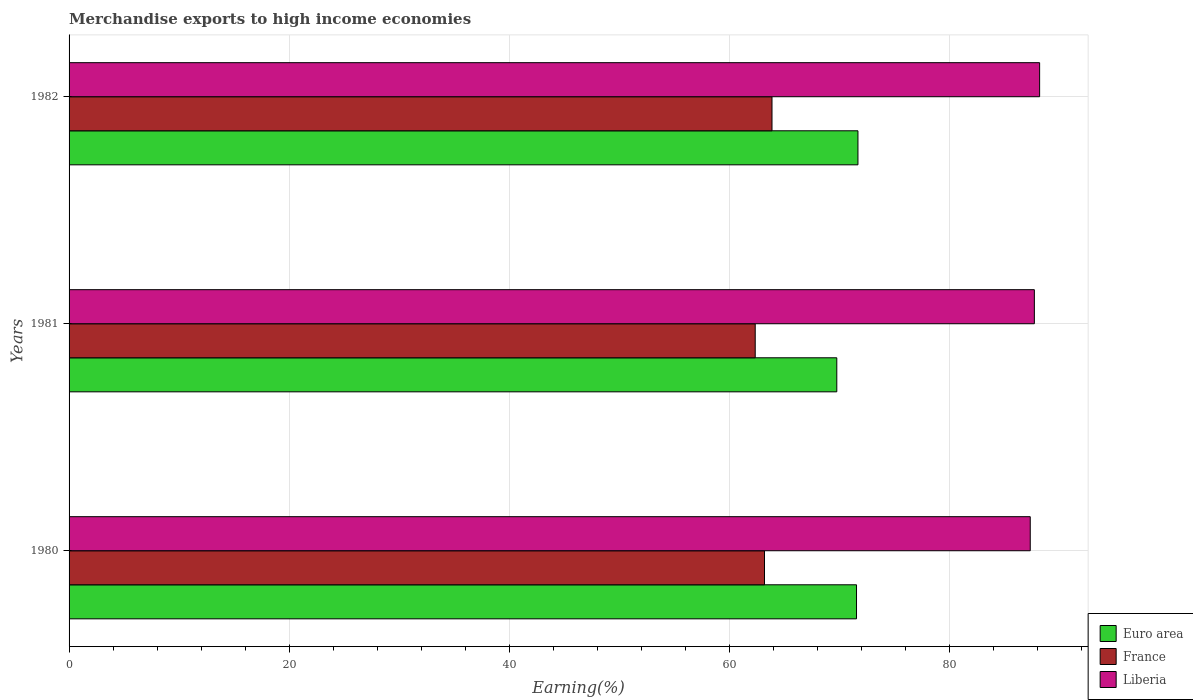How many different coloured bars are there?
Offer a terse response. 3. Are the number of bars per tick equal to the number of legend labels?
Your answer should be very brief. Yes. Are the number of bars on each tick of the Y-axis equal?
Keep it short and to the point. Yes. How many bars are there on the 1st tick from the top?
Ensure brevity in your answer.  3. In how many cases, is the number of bars for a given year not equal to the number of legend labels?
Provide a succinct answer. 0. What is the percentage of amount earned from merchandise exports in Liberia in 1981?
Provide a succinct answer. 87.71. Across all years, what is the maximum percentage of amount earned from merchandise exports in Liberia?
Provide a short and direct response. 88.19. Across all years, what is the minimum percentage of amount earned from merchandise exports in Liberia?
Make the answer very short. 87.34. What is the total percentage of amount earned from merchandise exports in Liberia in the graph?
Your response must be concise. 263.24. What is the difference between the percentage of amount earned from merchandise exports in Euro area in 1980 and that in 1982?
Your answer should be compact. -0.13. What is the difference between the percentage of amount earned from merchandise exports in Liberia in 1980 and the percentage of amount earned from merchandise exports in France in 1982?
Give a very brief answer. 23.47. What is the average percentage of amount earned from merchandise exports in France per year?
Keep it short and to the point. 63.14. In the year 1981, what is the difference between the percentage of amount earned from merchandise exports in France and percentage of amount earned from merchandise exports in Liberia?
Your response must be concise. -25.36. What is the ratio of the percentage of amount earned from merchandise exports in Liberia in 1981 to that in 1982?
Make the answer very short. 0.99. What is the difference between the highest and the second highest percentage of amount earned from merchandise exports in Liberia?
Your answer should be very brief. 0.48. What is the difference between the highest and the lowest percentage of amount earned from merchandise exports in Euro area?
Ensure brevity in your answer.  1.92. In how many years, is the percentage of amount earned from merchandise exports in Liberia greater than the average percentage of amount earned from merchandise exports in Liberia taken over all years?
Your response must be concise. 1. What does the 1st bar from the top in 1980 represents?
Offer a very short reply. Liberia. Does the graph contain grids?
Make the answer very short. Yes. Where does the legend appear in the graph?
Give a very brief answer. Bottom right. How many legend labels are there?
Your answer should be compact. 3. What is the title of the graph?
Offer a terse response. Merchandise exports to high income economies. Does "Uruguay" appear as one of the legend labels in the graph?
Your answer should be compact. No. What is the label or title of the X-axis?
Ensure brevity in your answer.  Earning(%). What is the Earning(%) in Euro area in 1980?
Make the answer very short. 71.55. What is the Earning(%) in France in 1980?
Keep it short and to the point. 63.19. What is the Earning(%) in Liberia in 1980?
Offer a terse response. 87.34. What is the Earning(%) of Euro area in 1981?
Offer a terse response. 69.76. What is the Earning(%) of France in 1981?
Provide a short and direct response. 62.35. What is the Earning(%) of Liberia in 1981?
Ensure brevity in your answer.  87.71. What is the Earning(%) of Euro area in 1982?
Provide a short and direct response. 71.68. What is the Earning(%) of France in 1982?
Your answer should be very brief. 63.87. What is the Earning(%) of Liberia in 1982?
Provide a succinct answer. 88.19. Across all years, what is the maximum Earning(%) in Euro area?
Provide a succinct answer. 71.68. Across all years, what is the maximum Earning(%) of France?
Keep it short and to the point. 63.87. Across all years, what is the maximum Earning(%) in Liberia?
Provide a short and direct response. 88.19. Across all years, what is the minimum Earning(%) of Euro area?
Your response must be concise. 69.76. Across all years, what is the minimum Earning(%) of France?
Your answer should be compact. 62.35. Across all years, what is the minimum Earning(%) in Liberia?
Offer a terse response. 87.34. What is the total Earning(%) of Euro area in the graph?
Your response must be concise. 213. What is the total Earning(%) of France in the graph?
Provide a succinct answer. 189.41. What is the total Earning(%) of Liberia in the graph?
Offer a terse response. 263.24. What is the difference between the Earning(%) of Euro area in 1980 and that in 1981?
Your answer should be very brief. 1.79. What is the difference between the Earning(%) of France in 1980 and that in 1981?
Keep it short and to the point. 0.84. What is the difference between the Earning(%) in Liberia in 1980 and that in 1981?
Offer a terse response. -0.37. What is the difference between the Earning(%) in Euro area in 1980 and that in 1982?
Your answer should be very brief. -0.13. What is the difference between the Earning(%) of France in 1980 and that in 1982?
Give a very brief answer. -0.68. What is the difference between the Earning(%) in Liberia in 1980 and that in 1982?
Offer a very short reply. -0.85. What is the difference between the Earning(%) in Euro area in 1981 and that in 1982?
Provide a succinct answer. -1.92. What is the difference between the Earning(%) of France in 1981 and that in 1982?
Keep it short and to the point. -1.53. What is the difference between the Earning(%) in Liberia in 1981 and that in 1982?
Keep it short and to the point. -0.48. What is the difference between the Earning(%) in Euro area in 1980 and the Earning(%) in France in 1981?
Keep it short and to the point. 9.2. What is the difference between the Earning(%) in Euro area in 1980 and the Earning(%) in Liberia in 1981?
Offer a very short reply. -16.16. What is the difference between the Earning(%) of France in 1980 and the Earning(%) of Liberia in 1981?
Offer a terse response. -24.52. What is the difference between the Earning(%) in Euro area in 1980 and the Earning(%) in France in 1982?
Ensure brevity in your answer.  7.68. What is the difference between the Earning(%) of Euro area in 1980 and the Earning(%) of Liberia in 1982?
Your response must be concise. -16.64. What is the difference between the Earning(%) in France in 1980 and the Earning(%) in Liberia in 1982?
Provide a succinct answer. -25. What is the difference between the Earning(%) in Euro area in 1981 and the Earning(%) in France in 1982?
Make the answer very short. 5.89. What is the difference between the Earning(%) of Euro area in 1981 and the Earning(%) of Liberia in 1982?
Provide a short and direct response. -18.43. What is the difference between the Earning(%) in France in 1981 and the Earning(%) in Liberia in 1982?
Provide a succinct answer. -25.84. What is the average Earning(%) of Euro area per year?
Offer a very short reply. 71. What is the average Earning(%) in France per year?
Your answer should be compact. 63.14. What is the average Earning(%) in Liberia per year?
Your response must be concise. 87.75. In the year 1980, what is the difference between the Earning(%) in Euro area and Earning(%) in France?
Make the answer very short. 8.36. In the year 1980, what is the difference between the Earning(%) in Euro area and Earning(%) in Liberia?
Ensure brevity in your answer.  -15.79. In the year 1980, what is the difference between the Earning(%) in France and Earning(%) in Liberia?
Ensure brevity in your answer.  -24.15. In the year 1981, what is the difference between the Earning(%) in Euro area and Earning(%) in France?
Make the answer very short. 7.41. In the year 1981, what is the difference between the Earning(%) of Euro area and Earning(%) of Liberia?
Provide a succinct answer. -17.95. In the year 1981, what is the difference between the Earning(%) in France and Earning(%) in Liberia?
Give a very brief answer. -25.36. In the year 1982, what is the difference between the Earning(%) of Euro area and Earning(%) of France?
Your answer should be compact. 7.81. In the year 1982, what is the difference between the Earning(%) of Euro area and Earning(%) of Liberia?
Offer a terse response. -16.51. In the year 1982, what is the difference between the Earning(%) of France and Earning(%) of Liberia?
Keep it short and to the point. -24.32. What is the ratio of the Earning(%) of Euro area in 1980 to that in 1981?
Offer a terse response. 1.03. What is the ratio of the Earning(%) in France in 1980 to that in 1981?
Make the answer very short. 1.01. What is the ratio of the Earning(%) of Liberia in 1980 to that in 1981?
Your answer should be very brief. 1. What is the ratio of the Earning(%) in France in 1980 to that in 1982?
Make the answer very short. 0.99. What is the ratio of the Earning(%) in Liberia in 1980 to that in 1982?
Your answer should be compact. 0.99. What is the ratio of the Earning(%) in Euro area in 1981 to that in 1982?
Make the answer very short. 0.97. What is the ratio of the Earning(%) in France in 1981 to that in 1982?
Provide a succinct answer. 0.98. What is the ratio of the Earning(%) in Liberia in 1981 to that in 1982?
Provide a succinct answer. 0.99. What is the difference between the highest and the second highest Earning(%) in Euro area?
Your response must be concise. 0.13. What is the difference between the highest and the second highest Earning(%) in France?
Make the answer very short. 0.68. What is the difference between the highest and the second highest Earning(%) in Liberia?
Offer a very short reply. 0.48. What is the difference between the highest and the lowest Earning(%) of Euro area?
Offer a very short reply. 1.92. What is the difference between the highest and the lowest Earning(%) in France?
Your answer should be compact. 1.53. What is the difference between the highest and the lowest Earning(%) in Liberia?
Your response must be concise. 0.85. 